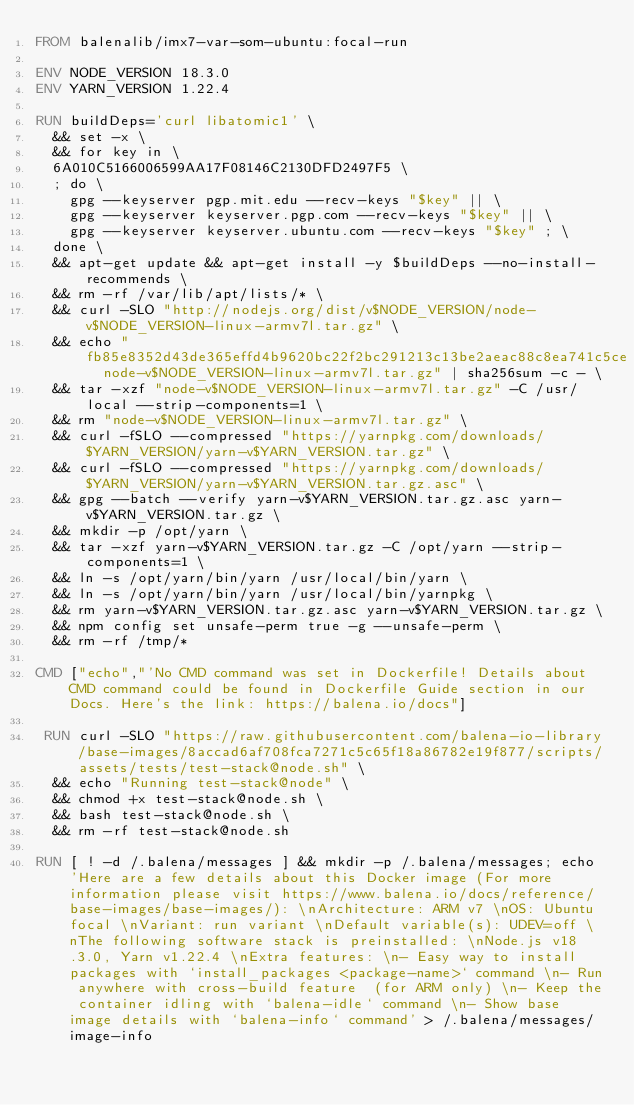<code> <loc_0><loc_0><loc_500><loc_500><_Dockerfile_>FROM balenalib/imx7-var-som-ubuntu:focal-run

ENV NODE_VERSION 18.3.0
ENV YARN_VERSION 1.22.4

RUN buildDeps='curl libatomic1' \
	&& set -x \
	&& for key in \
	6A010C5166006599AA17F08146C2130DFD2497F5 \
	; do \
		gpg --keyserver pgp.mit.edu --recv-keys "$key" || \
		gpg --keyserver keyserver.pgp.com --recv-keys "$key" || \
		gpg --keyserver keyserver.ubuntu.com --recv-keys "$key" ; \
	done \
	&& apt-get update && apt-get install -y $buildDeps --no-install-recommends \
	&& rm -rf /var/lib/apt/lists/* \
	&& curl -SLO "http://nodejs.org/dist/v$NODE_VERSION/node-v$NODE_VERSION-linux-armv7l.tar.gz" \
	&& echo "fb85e8352d43de365effd4b9620bc22f2bc291213c13be2aeac88c8ea741c5ce  node-v$NODE_VERSION-linux-armv7l.tar.gz" | sha256sum -c - \
	&& tar -xzf "node-v$NODE_VERSION-linux-armv7l.tar.gz" -C /usr/local --strip-components=1 \
	&& rm "node-v$NODE_VERSION-linux-armv7l.tar.gz" \
	&& curl -fSLO --compressed "https://yarnpkg.com/downloads/$YARN_VERSION/yarn-v$YARN_VERSION.tar.gz" \
	&& curl -fSLO --compressed "https://yarnpkg.com/downloads/$YARN_VERSION/yarn-v$YARN_VERSION.tar.gz.asc" \
	&& gpg --batch --verify yarn-v$YARN_VERSION.tar.gz.asc yarn-v$YARN_VERSION.tar.gz \
	&& mkdir -p /opt/yarn \
	&& tar -xzf yarn-v$YARN_VERSION.tar.gz -C /opt/yarn --strip-components=1 \
	&& ln -s /opt/yarn/bin/yarn /usr/local/bin/yarn \
	&& ln -s /opt/yarn/bin/yarn /usr/local/bin/yarnpkg \
	&& rm yarn-v$YARN_VERSION.tar.gz.asc yarn-v$YARN_VERSION.tar.gz \
	&& npm config set unsafe-perm true -g --unsafe-perm \
	&& rm -rf /tmp/*

CMD ["echo","'No CMD command was set in Dockerfile! Details about CMD command could be found in Dockerfile Guide section in our Docs. Here's the link: https://balena.io/docs"]

 RUN curl -SLO "https://raw.githubusercontent.com/balena-io-library/base-images/8accad6af708fca7271c5c65f18a86782e19f877/scripts/assets/tests/test-stack@node.sh" \
  && echo "Running test-stack@node" \
  && chmod +x test-stack@node.sh \
  && bash test-stack@node.sh \
  && rm -rf test-stack@node.sh 

RUN [ ! -d /.balena/messages ] && mkdir -p /.balena/messages; echo 'Here are a few details about this Docker image (For more information please visit https://www.balena.io/docs/reference/base-images/base-images/): \nArchitecture: ARM v7 \nOS: Ubuntu focal \nVariant: run variant \nDefault variable(s): UDEV=off \nThe following software stack is preinstalled: \nNode.js v18.3.0, Yarn v1.22.4 \nExtra features: \n- Easy way to install packages with `install_packages <package-name>` command \n- Run anywhere with cross-build feature  (for ARM only) \n- Keep the container idling with `balena-idle` command \n- Show base image details with `balena-info` command' > /.balena/messages/image-info</code> 